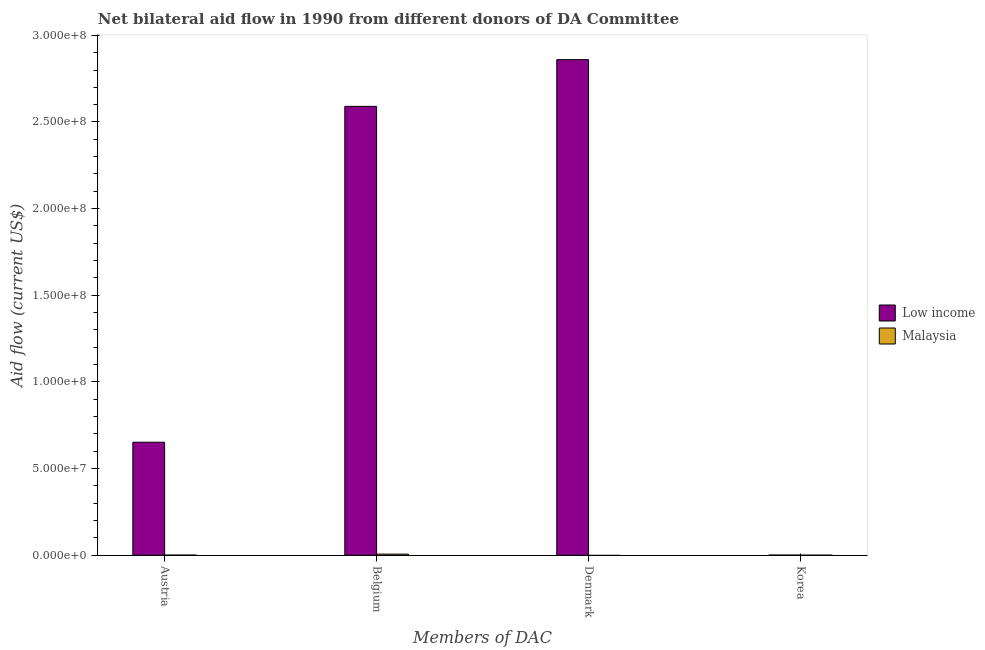How many different coloured bars are there?
Make the answer very short. 2. Are the number of bars per tick equal to the number of legend labels?
Give a very brief answer. No. Are the number of bars on each tick of the X-axis equal?
Offer a terse response. No. How many bars are there on the 4th tick from the left?
Your answer should be compact. 2. What is the label of the 3rd group of bars from the left?
Provide a short and direct response. Denmark. What is the amount of aid given by austria in Low income?
Offer a terse response. 6.52e+07. Across all countries, what is the maximum amount of aid given by austria?
Ensure brevity in your answer.  6.52e+07. Across all countries, what is the minimum amount of aid given by korea?
Keep it short and to the point. 5.00e+04. What is the total amount of aid given by korea in the graph?
Keep it short and to the point. 1.60e+05. What is the difference between the amount of aid given by korea in Low income and that in Malaysia?
Your response must be concise. 6.00e+04. What is the difference between the amount of aid given by denmark in Malaysia and the amount of aid given by belgium in Low income?
Provide a succinct answer. -2.59e+08. What is the average amount of aid given by austria per country?
Make the answer very short. 3.27e+07. What is the difference between the amount of aid given by korea and amount of aid given by austria in Malaysia?
Offer a very short reply. -4.00e+04. In how many countries, is the amount of aid given by korea greater than 80000000 US$?
Offer a very short reply. 0. What is the ratio of the amount of aid given by austria in Malaysia to that in Low income?
Offer a very short reply. 0. What is the difference between the highest and the second highest amount of aid given by belgium?
Keep it short and to the point. 2.58e+08. What is the difference between the highest and the lowest amount of aid given by korea?
Provide a succinct answer. 6.00e+04. In how many countries, is the amount of aid given by denmark greater than the average amount of aid given by denmark taken over all countries?
Provide a succinct answer. 1. Is the sum of the amount of aid given by austria in Malaysia and Low income greater than the maximum amount of aid given by denmark across all countries?
Your response must be concise. No. Are all the bars in the graph horizontal?
Make the answer very short. No. What is the difference between two consecutive major ticks on the Y-axis?
Your response must be concise. 5.00e+07. Does the graph contain grids?
Your response must be concise. No. How many legend labels are there?
Offer a terse response. 2. How are the legend labels stacked?
Ensure brevity in your answer.  Vertical. What is the title of the graph?
Your answer should be very brief. Net bilateral aid flow in 1990 from different donors of DA Committee. Does "Honduras" appear as one of the legend labels in the graph?
Make the answer very short. No. What is the label or title of the X-axis?
Offer a very short reply. Members of DAC. What is the label or title of the Y-axis?
Offer a terse response. Aid flow (current US$). What is the Aid flow (current US$) in Low income in Austria?
Your response must be concise. 6.52e+07. What is the Aid flow (current US$) of Malaysia in Austria?
Ensure brevity in your answer.  9.00e+04. What is the Aid flow (current US$) of Low income in Belgium?
Provide a succinct answer. 2.59e+08. What is the Aid flow (current US$) in Malaysia in Belgium?
Offer a very short reply. 6.50e+05. What is the Aid flow (current US$) of Low income in Denmark?
Keep it short and to the point. 2.86e+08. What is the Aid flow (current US$) in Malaysia in Denmark?
Provide a short and direct response. 0. What is the Aid flow (current US$) of Malaysia in Korea?
Make the answer very short. 5.00e+04. Across all Members of DAC, what is the maximum Aid flow (current US$) of Low income?
Your response must be concise. 2.86e+08. Across all Members of DAC, what is the maximum Aid flow (current US$) in Malaysia?
Your answer should be compact. 6.50e+05. Across all Members of DAC, what is the minimum Aid flow (current US$) of Low income?
Your answer should be very brief. 1.10e+05. What is the total Aid flow (current US$) of Low income in the graph?
Keep it short and to the point. 6.10e+08. What is the total Aid flow (current US$) in Malaysia in the graph?
Provide a succinct answer. 7.90e+05. What is the difference between the Aid flow (current US$) in Low income in Austria and that in Belgium?
Your answer should be compact. -1.94e+08. What is the difference between the Aid flow (current US$) in Malaysia in Austria and that in Belgium?
Ensure brevity in your answer.  -5.60e+05. What is the difference between the Aid flow (current US$) in Low income in Austria and that in Denmark?
Keep it short and to the point. -2.21e+08. What is the difference between the Aid flow (current US$) of Low income in Austria and that in Korea?
Offer a very short reply. 6.51e+07. What is the difference between the Aid flow (current US$) in Malaysia in Austria and that in Korea?
Provide a short and direct response. 4.00e+04. What is the difference between the Aid flow (current US$) of Low income in Belgium and that in Denmark?
Provide a short and direct response. -2.70e+07. What is the difference between the Aid flow (current US$) in Low income in Belgium and that in Korea?
Your response must be concise. 2.59e+08. What is the difference between the Aid flow (current US$) of Low income in Denmark and that in Korea?
Provide a succinct answer. 2.86e+08. What is the difference between the Aid flow (current US$) in Low income in Austria and the Aid flow (current US$) in Malaysia in Belgium?
Your answer should be compact. 6.46e+07. What is the difference between the Aid flow (current US$) in Low income in Austria and the Aid flow (current US$) in Malaysia in Korea?
Your response must be concise. 6.52e+07. What is the difference between the Aid flow (current US$) of Low income in Belgium and the Aid flow (current US$) of Malaysia in Korea?
Offer a terse response. 2.59e+08. What is the difference between the Aid flow (current US$) of Low income in Denmark and the Aid flow (current US$) of Malaysia in Korea?
Offer a terse response. 2.86e+08. What is the average Aid flow (current US$) in Low income per Members of DAC?
Offer a terse response. 1.53e+08. What is the average Aid flow (current US$) of Malaysia per Members of DAC?
Your answer should be compact. 1.98e+05. What is the difference between the Aid flow (current US$) in Low income and Aid flow (current US$) in Malaysia in Austria?
Your response must be concise. 6.51e+07. What is the difference between the Aid flow (current US$) of Low income and Aid flow (current US$) of Malaysia in Belgium?
Give a very brief answer. 2.58e+08. What is the difference between the Aid flow (current US$) in Low income and Aid flow (current US$) in Malaysia in Korea?
Give a very brief answer. 6.00e+04. What is the ratio of the Aid flow (current US$) in Low income in Austria to that in Belgium?
Ensure brevity in your answer.  0.25. What is the ratio of the Aid flow (current US$) of Malaysia in Austria to that in Belgium?
Your answer should be very brief. 0.14. What is the ratio of the Aid flow (current US$) of Low income in Austria to that in Denmark?
Offer a terse response. 0.23. What is the ratio of the Aid flow (current US$) in Low income in Austria to that in Korea?
Keep it short and to the point. 592.91. What is the ratio of the Aid flow (current US$) of Malaysia in Austria to that in Korea?
Offer a terse response. 1.8. What is the ratio of the Aid flow (current US$) of Low income in Belgium to that in Denmark?
Provide a succinct answer. 0.91. What is the ratio of the Aid flow (current US$) of Low income in Belgium to that in Korea?
Offer a very short reply. 2354.64. What is the ratio of the Aid flow (current US$) in Low income in Denmark to that in Korea?
Provide a succinct answer. 2599.73. What is the difference between the highest and the second highest Aid flow (current US$) of Low income?
Offer a terse response. 2.70e+07. What is the difference between the highest and the second highest Aid flow (current US$) in Malaysia?
Offer a very short reply. 5.60e+05. What is the difference between the highest and the lowest Aid flow (current US$) of Low income?
Give a very brief answer. 2.86e+08. What is the difference between the highest and the lowest Aid flow (current US$) of Malaysia?
Make the answer very short. 6.50e+05. 